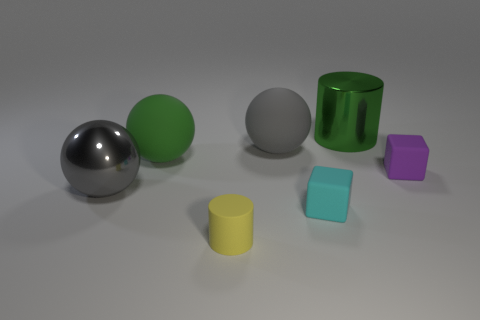Subtract all big green spheres. How many spheres are left? 2 Add 1 tiny green cubes. How many objects exist? 8 Subtract 2 cylinders. How many cylinders are left? 0 Subtract all green balls. How many balls are left? 2 Subtract all blocks. How many objects are left? 5 Add 4 cyan objects. How many cyan objects exist? 5 Subtract 0 brown balls. How many objects are left? 7 Subtract all purple cylinders. Subtract all blue blocks. How many cylinders are left? 2 Subtract all cyan spheres. How many yellow cubes are left? 0 Subtract all rubber objects. Subtract all large gray shiny spheres. How many objects are left? 1 